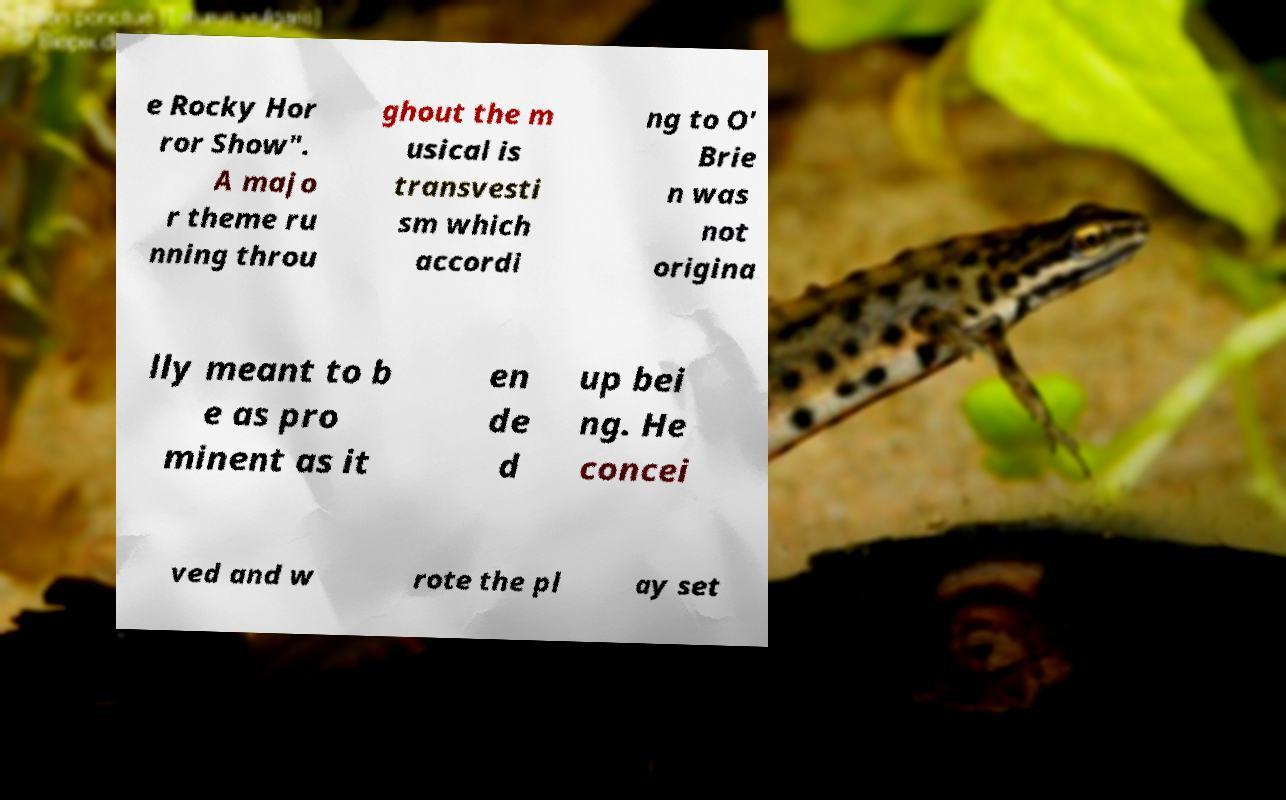There's text embedded in this image that I need extracted. Can you transcribe it verbatim? e Rocky Hor ror Show". A majo r theme ru nning throu ghout the m usical is transvesti sm which accordi ng to O' Brie n was not origina lly meant to b e as pro minent as it en de d up bei ng. He concei ved and w rote the pl ay set 